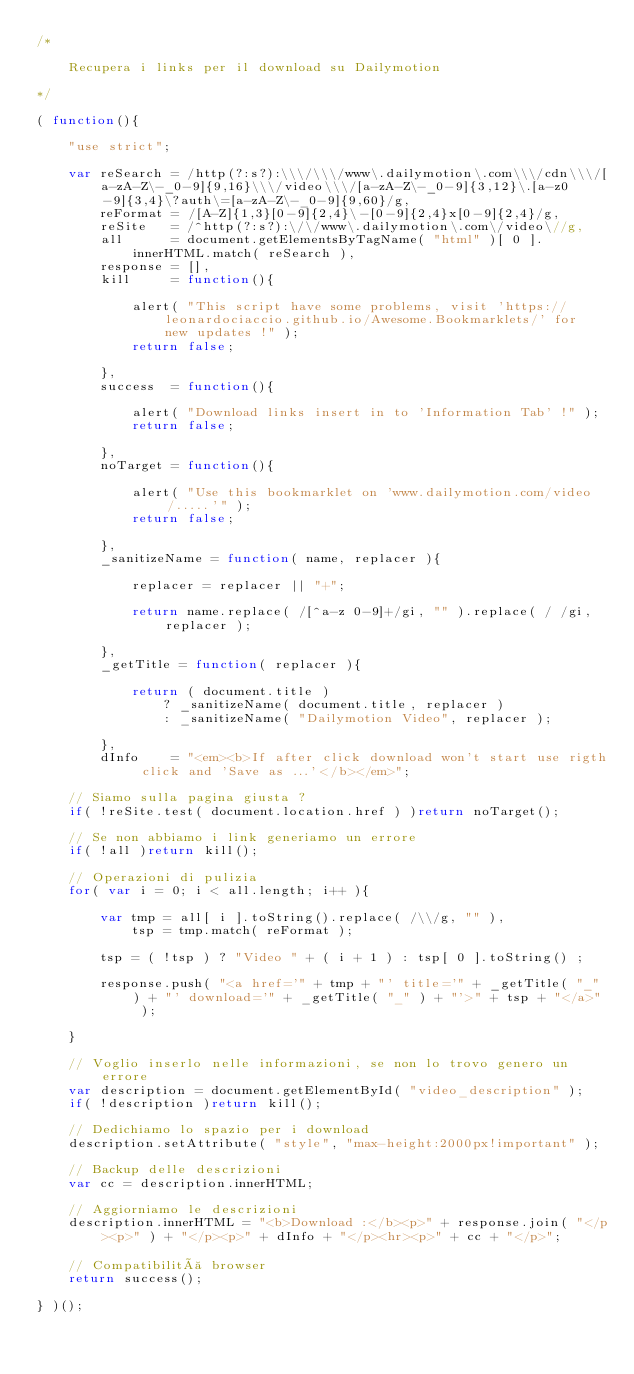Convert code to text. <code><loc_0><loc_0><loc_500><loc_500><_JavaScript_>/*

    Recupera i links per il download su Dailymotion

*/

( function(){
    
    "use strict";

    var reSearch = /http(?:s?):\\\/\\\/www\.dailymotion\.com\\\/cdn\\\/[a-zA-Z\-_0-9]{9,16}\\\/video\\\/[a-zA-Z\-_0-9]{3,12}\.[a-z0-9]{3,4}\?auth\=[a-zA-Z\-_0-9]{9,60}/g,
        reFormat = /[A-Z]{1,3}[0-9]{2,4}\-[0-9]{2,4}x[0-9]{2,4}/g,
        reSite   = /^http(?:s?):\/\/www\.dailymotion\.com\/video\//g,
        all      = document.getElementsByTagName( "html" )[ 0 ].innerHTML.match( reSearch ),
        response = [],
        kill     = function(){
        
            alert( "This script have some problems, visit 'https://leonardociaccio.github.io/Awesome.Bookmarklets/' for new updates !" );
            return false;
        
        },
        success  = function(){
        
            alert( "Download links insert in to 'Information Tab' !" );
            return false;
        
        },
        noTarget = function(){
        
            alert( "Use this bookmarklet on 'www.dailymotion.com/video/.....'" );
            return false;
        
        },
        _sanitizeName = function( name, replacer ){			
        
            replacer = replacer || "+";

            return name.replace( /[^a-z 0-9]+/gi, "" ).replace( / /gi, replacer );	

        },
        _getTitle = function( replacer ){     
        
            return ( document.title ) 
                ? _sanitizeName( document.title, replacer ) 
                : _sanitizeName( "Dailymotion Video", replacer );

        },
        dInfo    = "<em><b>If after click download won't start use rigth click and 'Save as ...'</b></em>";
    
    // Siamo sulla pagina giusta ?
    if( !reSite.test( document.location.href ) )return noTarget();
    
    // Se non abbiamo i link generiamo un errore
    if( !all )return kill();
    
    // Operazioni di pulizia
    for( var i = 0; i < all.length; i++ ){
        
        var tmp = all[ i ].toString().replace( /\\/g, "" ),
            tsp = tmp.match( reFormat );
        
        tsp = ( !tsp ) ? "Video " + ( i + 1 ) : tsp[ 0 ].toString() ;
        
        response.push( "<a href='" + tmp + "' title='" + _getTitle( "_" ) + "' download='" + _getTitle( "_" ) + "'>" + tsp + "</a>" );
    
    }
    
    // Voglio inserlo nelle informazioni, se non lo trovo genero un errore
    var description = document.getElementById( "video_description" );
    if( !description )return kill();
    
    // Dedichiamo lo spazio per i download            
    description.setAttribute( "style", "max-height:2000px!important" );
    
    // Backup delle descrizioni
    var cc = description.innerHTML;
    
    // Aggiorniamo le descrizioni
    description.innerHTML = "<b>Download :</b><p>" + response.join( "</p><p>" ) + "</p><p>" + dInfo + "</p><hr><p>" + cc + "</p>";    
    
    // Compatibilità browser
    return success();

} )();








</code> 